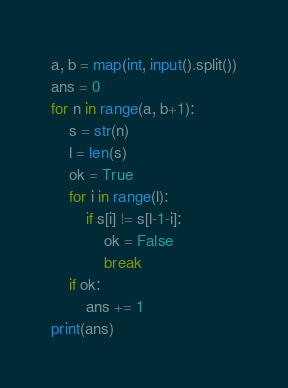Convert code to text. <code><loc_0><loc_0><loc_500><loc_500><_Python_>a, b = map(int, input().split())
ans = 0
for n in range(a, b+1):
    s = str(n)
    l = len(s)
    ok = True
    for i in range(l):
        if s[i] != s[l-1-i]:
            ok = False
            break
    if ok:
        ans += 1
print(ans)</code> 